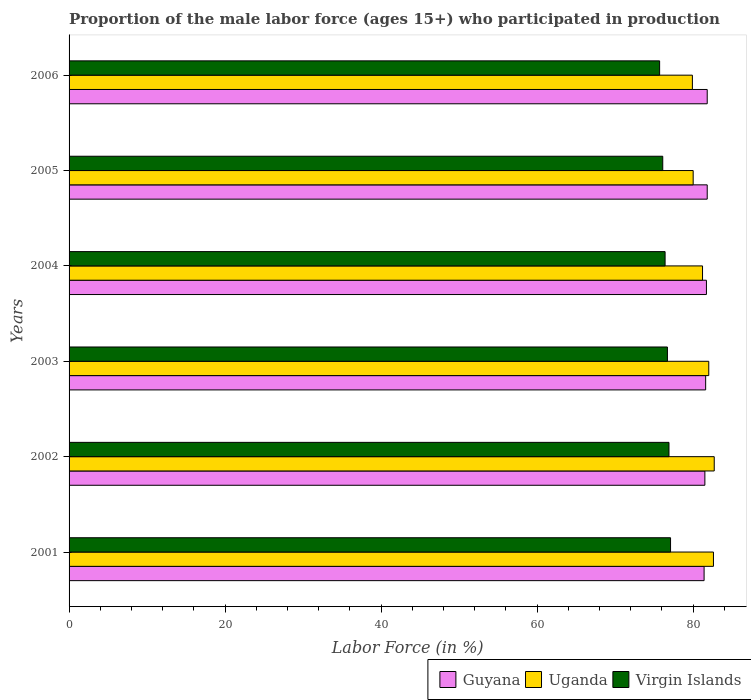How many groups of bars are there?
Give a very brief answer. 6. Are the number of bars per tick equal to the number of legend labels?
Your answer should be very brief. Yes. Are the number of bars on each tick of the Y-axis equal?
Provide a succinct answer. Yes. How many bars are there on the 2nd tick from the top?
Provide a short and direct response. 3. In how many cases, is the number of bars for a given year not equal to the number of legend labels?
Make the answer very short. 0. What is the proportion of the male labor force who participated in production in Virgin Islands in 2001?
Offer a very short reply. 77.1. Across all years, what is the maximum proportion of the male labor force who participated in production in Guyana?
Offer a terse response. 81.8. Across all years, what is the minimum proportion of the male labor force who participated in production in Virgin Islands?
Keep it short and to the point. 75.7. In which year was the proportion of the male labor force who participated in production in Guyana maximum?
Provide a succinct answer. 2005. In which year was the proportion of the male labor force who participated in production in Virgin Islands minimum?
Keep it short and to the point. 2006. What is the total proportion of the male labor force who participated in production in Guyana in the graph?
Offer a very short reply. 489.8. What is the difference between the proportion of the male labor force who participated in production in Virgin Islands in 2001 and that in 2006?
Give a very brief answer. 1.4. What is the difference between the proportion of the male labor force who participated in production in Virgin Islands in 2006 and the proportion of the male labor force who participated in production in Uganda in 2003?
Your answer should be compact. -6.3. What is the average proportion of the male labor force who participated in production in Uganda per year?
Ensure brevity in your answer.  81.4. In the year 2006, what is the difference between the proportion of the male labor force who participated in production in Virgin Islands and proportion of the male labor force who participated in production in Uganda?
Ensure brevity in your answer.  -4.2. What is the ratio of the proportion of the male labor force who participated in production in Guyana in 2001 to that in 2002?
Your answer should be compact. 1. Is the proportion of the male labor force who participated in production in Virgin Islands in 2001 less than that in 2002?
Provide a succinct answer. No. Is the difference between the proportion of the male labor force who participated in production in Virgin Islands in 2003 and 2004 greater than the difference between the proportion of the male labor force who participated in production in Uganda in 2003 and 2004?
Provide a short and direct response. No. What is the difference between the highest and the second highest proportion of the male labor force who participated in production in Uganda?
Ensure brevity in your answer.  0.1. What is the difference between the highest and the lowest proportion of the male labor force who participated in production in Uganda?
Offer a very short reply. 2.8. In how many years, is the proportion of the male labor force who participated in production in Guyana greater than the average proportion of the male labor force who participated in production in Guyana taken over all years?
Provide a short and direct response. 3. Is the sum of the proportion of the male labor force who participated in production in Uganda in 2002 and 2005 greater than the maximum proportion of the male labor force who participated in production in Guyana across all years?
Provide a succinct answer. Yes. What does the 3rd bar from the top in 2004 represents?
Make the answer very short. Guyana. What does the 2nd bar from the bottom in 2004 represents?
Offer a terse response. Uganda. How many bars are there?
Offer a very short reply. 18. Are all the bars in the graph horizontal?
Your answer should be compact. Yes. How many years are there in the graph?
Ensure brevity in your answer.  6. What is the difference between two consecutive major ticks on the X-axis?
Offer a very short reply. 20. Does the graph contain grids?
Your answer should be compact. No. How are the legend labels stacked?
Provide a short and direct response. Horizontal. What is the title of the graph?
Your answer should be very brief. Proportion of the male labor force (ages 15+) who participated in production. What is the label or title of the Y-axis?
Ensure brevity in your answer.  Years. What is the Labor Force (in %) of Guyana in 2001?
Give a very brief answer. 81.4. What is the Labor Force (in %) in Uganda in 2001?
Ensure brevity in your answer.  82.6. What is the Labor Force (in %) of Virgin Islands in 2001?
Offer a very short reply. 77.1. What is the Labor Force (in %) in Guyana in 2002?
Your answer should be very brief. 81.5. What is the Labor Force (in %) of Uganda in 2002?
Ensure brevity in your answer.  82.7. What is the Labor Force (in %) in Virgin Islands in 2002?
Offer a terse response. 76.9. What is the Labor Force (in %) in Guyana in 2003?
Keep it short and to the point. 81.6. What is the Labor Force (in %) in Virgin Islands in 2003?
Ensure brevity in your answer.  76.7. What is the Labor Force (in %) in Guyana in 2004?
Your response must be concise. 81.7. What is the Labor Force (in %) of Uganda in 2004?
Provide a short and direct response. 81.2. What is the Labor Force (in %) of Virgin Islands in 2004?
Offer a terse response. 76.4. What is the Labor Force (in %) in Guyana in 2005?
Your response must be concise. 81.8. What is the Labor Force (in %) of Uganda in 2005?
Give a very brief answer. 80. What is the Labor Force (in %) of Virgin Islands in 2005?
Offer a terse response. 76.1. What is the Labor Force (in %) in Guyana in 2006?
Provide a short and direct response. 81.8. What is the Labor Force (in %) in Uganda in 2006?
Your response must be concise. 79.9. What is the Labor Force (in %) of Virgin Islands in 2006?
Your response must be concise. 75.7. Across all years, what is the maximum Labor Force (in %) in Guyana?
Offer a very short reply. 81.8. Across all years, what is the maximum Labor Force (in %) of Uganda?
Your answer should be compact. 82.7. Across all years, what is the maximum Labor Force (in %) of Virgin Islands?
Ensure brevity in your answer.  77.1. Across all years, what is the minimum Labor Force (in %) in Guyana?
Your response must be concise. 81.4. Across all years, what is the minimum Labor Force (in %) in Uganda?
Offer a terse response. 79.9. Across all years, what is the minimum Labor Force (in %) of Virgin Islands?
Ensure brevity in your answer.  75.7. What is the total Labor Force (in %) in Guyana in the graph?
Ensure brevity in your answer.  489.8. What is the total Labor Force (in %) in Uganda in the graph?
Keep it short and to the point. 488.4. What is the total Labor Force (in %) in Virgin Islands in the graph?
Your response must be concise. 458.9. What is the difference between the Labor Force (in %) of Guyana in 2001 and that in 2002?
Keep it short and to the point. -0.1. What is the difference between the Labor Force (in %) in Uganda in 2001 and that in 2002?
Your answer should be compact. -0.1. What is the difference between the Labor Force (in %) of Guyana in 2001 and that in 2004?
Provide a short and direct response. -0.3. What is the difference between the Labor Force (in %) in Guyana in 2001 and that in 2006?
Your answer should be very brief. -0.4. What is the difference between the Labor Force (in %) of Virgin Islands in 2001 and that in 2006?
Your answer should be very brief. 1.4. What is the difference between the Labor Force (in %) in Guyana in 2002 and that in 2003?
Make the answer very short. -0.1. What is the difference between the Labor Force (in %) of Uganda in 2002 and that in 2003?
Your response must be concise. 0.7. What is the difference between the Labor Force (in %) in Virgin Islands in 2002 and that in 2003?
Keep it short and to the point. 0.2. What is the difference between the Labor Force (in %) in Virgin Islands in 2002 and that in 2004?
Make the answer very short. 0.5. What is the difference between the Labor Force (in %) of Guyana in 2002 and that in 2005?
Ensure brevity in your answer.  -0.3. What is the difference between the Labor Force (in %) in Virgin Islands in 2002 and that in 2005?
Offer a terse response. 0.8. What is the difference between the Labor Force (in %) of Uganda in 2002 and that in 2006?
Offer a very short reply. 2.8. What is the difference between the Labor Force (in %) in Virgin Islands in 2002 and that in 2006?
Ensure brevity in your answer.  1.2. What is the difference between the Labor Force (in %) of Virgin Islands in 2003 and that in 2004?
Provide a short and direct response. 0.3. What is the difference between the Labor Force (in %) in Virgin Islands in 2003 and that in 2005?
Offer a very short reply. 0.6. What is the difference between the Labor Force (in %) in Guyana in 2003 and that in 2006?
Your answer should be very brief. -0.2. What is the difference between the Labor Force (in %) of Uganda in 2003 and that in 2006?
Give a very brief answer. 2.1. What is the difference between the Labor Force (in %) of Uganda in 2004 and that in 2005?
Provide a short and direct response. 1.2. What is the difference between the Labor Force (in %) of Guyana in 2004 and that in 2006?
Offer a terse response. -0.1. What is the difference between the Labor Force (in %) of Guyana in 2005 and that in 2006?
Ensure brevity in your answer.  0. What is the difference between the Labor Force (in %) of Uganda in 2005 and that in 2006?
Ensure brevity in your answer.  0.1. What is the difference between the Labor Force (in %) of Uganda in 2001 and the Labor Force (in %) of Virgin Islands in 2002?
Make the answer very short. 5.7. What is the difference between the Labor Force (in %) in Guyana in 2001 and the Labor Force (in %) in Uganda in 2003?
Give a very brief answer. -0.6. What is the difference between the Labor Force (in %) of Guyana in 2001 and the Labor Force (in %) of Uganda in 2004?
Your answer should be compact. 0.2. What is the difference between the Labor Force (in %) in Guyana in 2001 and the Labor Force (in %) in Virgin Islands in 2004?
Your answer should be compact. 5. What is the difference between the Labor Force (in %) of Guyana in 2001 and the Labor Force (in %) of Uganda in 2005?
Ensure brevity in your answer.  1.4. What is the difference between the Labor Force (in %) of Guyana in 2001 and the Labor Force (in %) of Virgin Islands in 2005?
Your answer should be very brief. 5.3. What is the difference between the Labor Force (in %) in Uganda in 2001 and the Labor Force (in %) in Virgin Islands in 2006?
Ensure brevity in your answer.  6.9. What is the difference between the Labor Force (in %) of Guyana in 2002 and the Labor Force (in %) of Virgin Islands in 2003?
Offer a very short reply. 4.8. What is the difference between the Labor Force (in %) in Uganda in 2002 and the Labor Force (in %) in Virgin Islands in 2003?
Your answer should be compact. 6. What is the difference between the Labor Force (in %) in Guyana in 2002 and the Labor Force (in %) in Uganda in 2004?
Your answer should be compact. 0.3. What is the difference between the Labor Force (in %) in Guyana in 2002 and the Labor Force (in %) in Virgin Islands in 2004?
Your response must be concise. 5.1. What is the difference between the Labor Force (in %) of Guyana in 2002 and the Labor Force (in %) of Uganda in 2005?
Ensure brevity in your answer.  1.5. What is the difference between the Labor Force (in %) in Guyana in 2002 and the Labor Force (in %) in Virgin Islands in 2005?
Provide a succinct answer. 5.4. What is the difference between the Labor Force (in %) of Guyana in 2003 and the Labor Force (in %) of Virgin Islands in 2004?
Your response must be concise. 5.2. What is the difference between the Labor Force (in %) of Uganda in 2003 and the Labor Force (in %) of Virgin Islands in 2004?
Ensure brevity in your answer.  5.6. What is the difference between the Labor Force (in %) in Guyana in 2003 and the Labor Force (in %) in Virgin Islands in 2006?
Your answer should be compact. 5.9. What is the difference between the Labor Force (in %) of Guyana in 2004 and the Labor Force (in %) of Virgin Islands in 2005?
Your answer should be compact. 5.6. What is the difference between the Labor Force (in %) of Uganda in 2004 and the Labor Force (in %) of Virgin Islands in 2005?
Give a very brief answer. 5.1. What is the difference between the Labor Force (in %) of Guyana in 2004 and the Labor Force (in %) of Uganda in 2006?
Your answer should be compact. 1.8. What is the difference between the Labor Force (in %) in Uganda in 2004 and the Labor Force (in %) in Virgin Islands in 2006?
Your answer should be very brief. 5.5. What is the difference between the Labor Force (in %) of Uganda in 2005 and the Labor Force (in %) of Virgin Islands in 2006?
Your response must be concise. 4.3. What is the average Labor Force (in %) of Guyana per year?
Make the answer very short. 81.63. What is the average Labor Force (in %) of Uganda per year?
Offer a terse response. 81.4. What is the average Labor Force (in %) of Virgin Islands per year?
Offer a terse response. 76.48. In the year 2001, what is the difference between the Labor Force (in %) in Guyana and Labor Force (in %) in Uganda?
Provide a succinct answer. -1.2. In the year 2001, what is the difference between the Labor Force (in %) in Guyana and Labor Force (in %) in Virgin Islands?
Keep it short and to the point. 4.3. In the year 2003, what is the difference between the Labor Force (in %) of Guyana and Labor Force (in %) of Virgin Islands?
Provide a short and direct response. 4.9. In the year 2003, what is the difference between the Labor Force (in %) in Uganda and Labor Force (in %) in Virgin Islands?
Provide a short and direct response. 5.3. In the year 2004, what is the difference between the Labor Force (in %) in Uganda and Labor Force (in %) in Virgin Islands?
Offer a terse response. 4.8. In the year 2005, what is the difference between the Labor Force (in %) of Guyana and Labor Force (in %) of Virgin Islands?
Give a very brief answer. 5.7. What is the ratio of the Labor Force (in %) in Guyana in 2001 to that in 2003?
Ensure brevity in your answer.  1. What is the ratio of the Labor Force (in %) of Uganda in 2001 to that in 2003?
Provide a succinct answer. 1.01. What is the ratio of the Labor Force (in %) of Uganda in 2001 to that in 2004?
Your response must be concise. 1.02. What is the ratio of the Labor Force (in %) of Virgin Islands in 2001 to that in 2004?
Your answer should be very brief. 1.01. What is the ratio of the Labor Force (in %) in Guyana in 2001 to that in 2005?
Give a very brief answer. 1. What is the ratio of the Labor Force (in %) of Uganda in 2001 to that in 2005?
Offer a very short reply. 1.03. What is the ratio of the Labor Force (in %) of Virgin Islands in 2001 to that in 2005?
Give a very brief answer. 1.01. What is the ratio of the Labor Force (in %) in Uganda in 2001 to that in 2006?
Ensure brevity in your answer.  1.03. What is the ratio of the Labor Force (in %) of Virgin Islands in 2001 to that in 2006?
Offer a terse response. 1.02. What is the ratio of the Labor Force (in %) in Uganda in 2002 to that in 2003?
Provide a short and direct response. 1.01. What is the ratio of the Labor Force (in %) of Uganda in 2002 to that in 2004?
Offer a terse response. 1.02. What is the ratio of the Labor Force (in %) in Virgin Islands in 2002 to that in 2004?
Your answer should be very brief. 1.01. What is the ratio of the Labor Force (in %) of Uganda in 2002 to that in 2005?
Keep it short and to the point. 1.03. What is the ratio of the Labor Force (in %) of Virgin Islands in 2002 to that in 2005?
Offer a very short reply. 1.01. What is the ratio of the Labor Force (in %) of Guyana in 2002 to that in 2006?
Ensure brevity in your answer.  1. What is the ratio of the Labor Force (in %) of Uganda in 2002 to that in 2006?
Provide a short and direct response. 1.03. What is the ratio of the Labor Force (in %) of Virgin Islands in 2002 to that in 2006?
Make the answer very short. 1.02. What is the ratio of the Labor Force (in %) in Uganda in 2003 to that in 2004?
Your answer should be very brief. 1.01. What is the ratio of the Labor Force (in %) of Virgin Islands in 2003 to that in 2005?
Keep it short and to the point. 1.01. What is the ratio of the Labor Force (in %) in Guyana in 2003 to that in 2006?
Your answer should be very brief. 1. What is the ratio of the Labor Force (in %) in Uganda in 2003 to that in 2006?
Ensure brevity in your answer.  1.03. What is the ratio of the Labor Force (in %) in Virgin Islands in 2003 to that in 2006?
Your response must be concise. 1.01. What is the ratio of the Labor Force (in %) in Uganda in 2004 to that in 2005?
Make the answer very short. 1.01. What is the ratio of the Labor Force (in %) in Uganda in 2004 to that in 2006?
Ensure brevity in your answer.  1.02. What is the ratio of the Labor Force (in %) in Virgin Islands in 2004 to that in 2006?
Provide a short and direct response. 1.01. What is the ratio of the Labor Force (in %) of Guyana in 2005 to that in 2006?
Give a very brief answer. 1. What is the ratio of the Labor Force (in %) in Virgin Islands in 2005 to that in 2006?
Provide a succinct answer. 1.01. What is the difference between the highest and the second highest Labor Force (in %) in Guyana?
Offer a very short reply. 0. What is the difference between the highest and the second highest Labor Force (in %) in Virgin Islands?
Your answer should be very brief. 0.2. What is the difference between the highest and the lowest Labor Force (in %) of Guyana?
Your answer should be compact. 0.4. What is the difference between the highest and the lowest Labor Force (in %) of Uganda?
Ensure brevity in your answer.  2.8. 